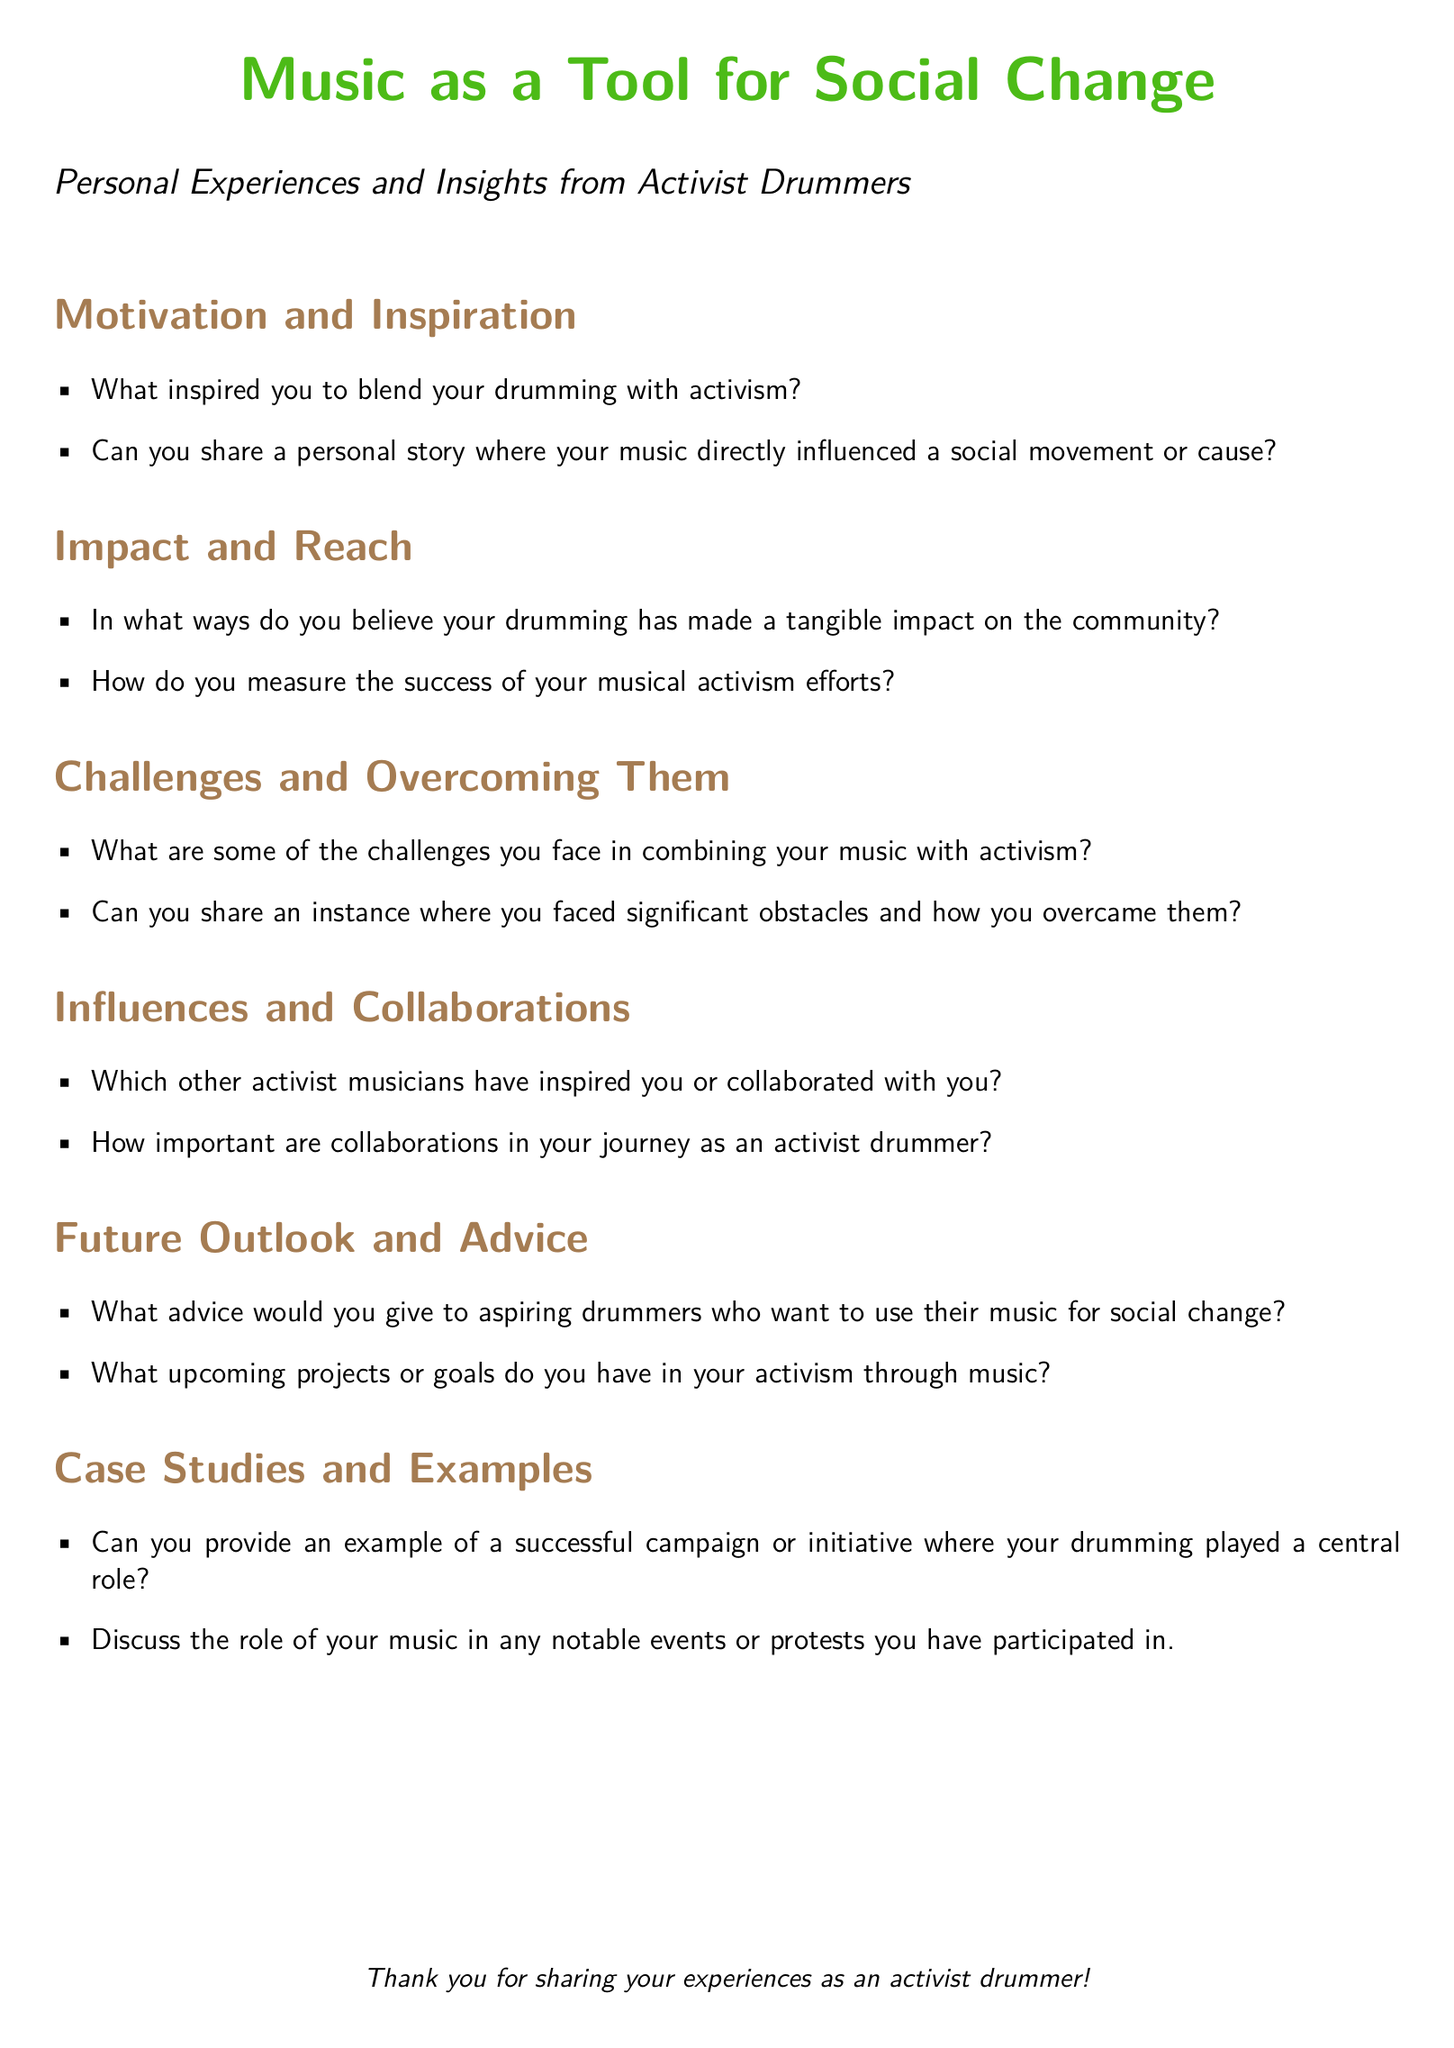What is the main theme of the document? The document focuses on the role of music, particularly drumming, as a tool for social change through personal experiences and insights from activist drummers.
Answer: Music as a Tool for Social Change How many sections are in the document? The document is divided into six sections, each addressing different aspects of activist drummers' experiences and insights.
Answer: Six What is one challenge mentioned that activist drummers face? One of the challenges mentioned in the document includes obstacles faced when combining music with activism.
Answer: Challenges What advice is sought for aspiring drummers? The document requests advice for aspiring drummers who want to use their music for social change.
Answer: Advice for aspiring drummers Which color is used for the title in the document? The title is displayed in the color 'activismgreen', which is specified in the document.
Answer: Activism Green What type of questions are included in the "Future Outlook and Advice" section? This section includes questions related to advice for aspiring drummers and future projects in activism through music.
Answer: Advice and future projects Can you name one aspect being discussed in the "Impact and Reach" section? The section discusses how drumming has made a tangible impact on the community and measuring success in musical activism efforts.
Answer: Tangible impact and measuring success What type of document is this? The document is a questionnaire designed to gather insights and experiences from activist drummers regarding their use of music for social change.
Answer: Questionnaire 